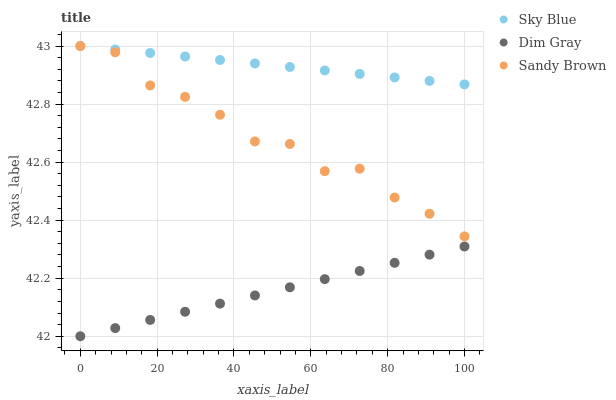Does Dim Gray have the minimum area under the curve?
Answer yes or no. Yes. Does Sky Blue have the maximum area under the curve?
Answer yes or no. Yes. Does Sandy Brown have the minimum area under the curve?
Answer yes or no. No. Does Sandy Brown have the maximum area under the curve?
Answer yes or no. No. Is Sky Blue the smoothest?
Answer yes or no. Yes. Is Sandy Brown the roughest?
Answer yes or no. Yes. Is Dim Gray the smoothest?
Answer yes or no. No. Is Dim Gray the roughest?
Answer yes or no. No. Does Dim Gray have the lowest value?
Answer yes or no. Yes. Does Sandy Brown have the lowest value?
Answer yes or no. No. Does Sandy Brown have the highest value?
Answer yes or no. Yes. Does Dim Gray have the highest value?
Answer yes or no. No. Is Dim Gray less than Sky Blue?
Answer yes or no. Yes. Is Sky Blue greater than Dim Gray?
Answer yes or no. Yes. Does Sky Blue intersect Sandy Brown?
Answer yes or no. Yes. Is Sky Blue less than Sandy Brown?
Answer yes or no. No. Is Sky Blue greater than Sandy Brown?
Answer yes or no. No. Does Dim Gray intersect Sky Blue?
Answer yes or no. No. 